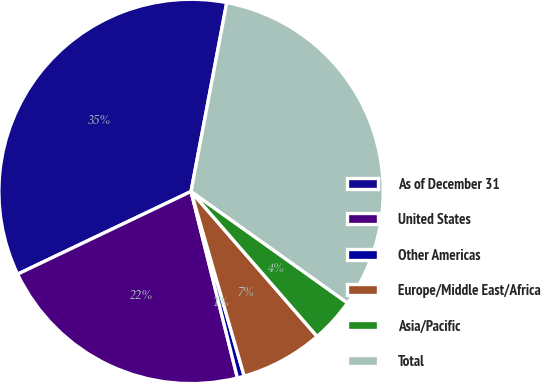Convert chart. <chart><loc_0><loc_0><loc_500><loc_500><pie_chart><fcel>As of December 31<fcel>United States<fcel>Other Americas<fcel>Europe/Middle East/Africa<fcel>Asia/Pacific<fcel>Total<nl><fcel>35.06%<fcel>21.8%<fcel>0.58%<fcel>6.93%<fcel>3.76%<fcel>31.88%<nl></chart> 